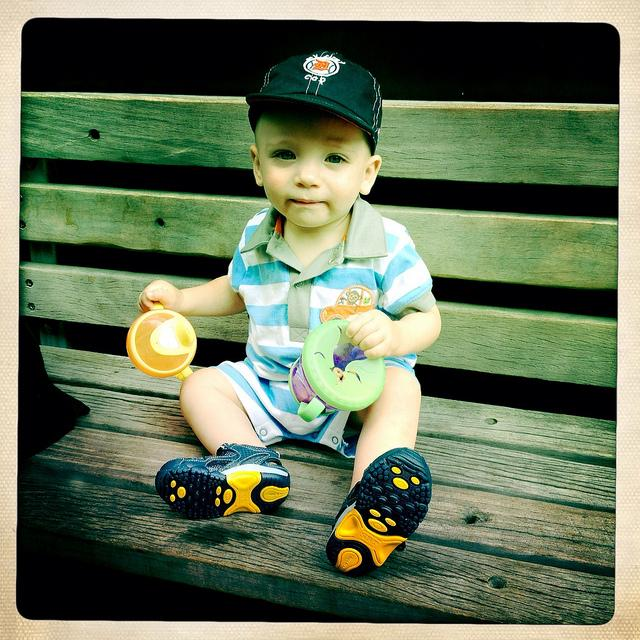What book series does he probably like? Please explain your reasoning. curious george. The kid is still really young and probably likes cartoon animals. 